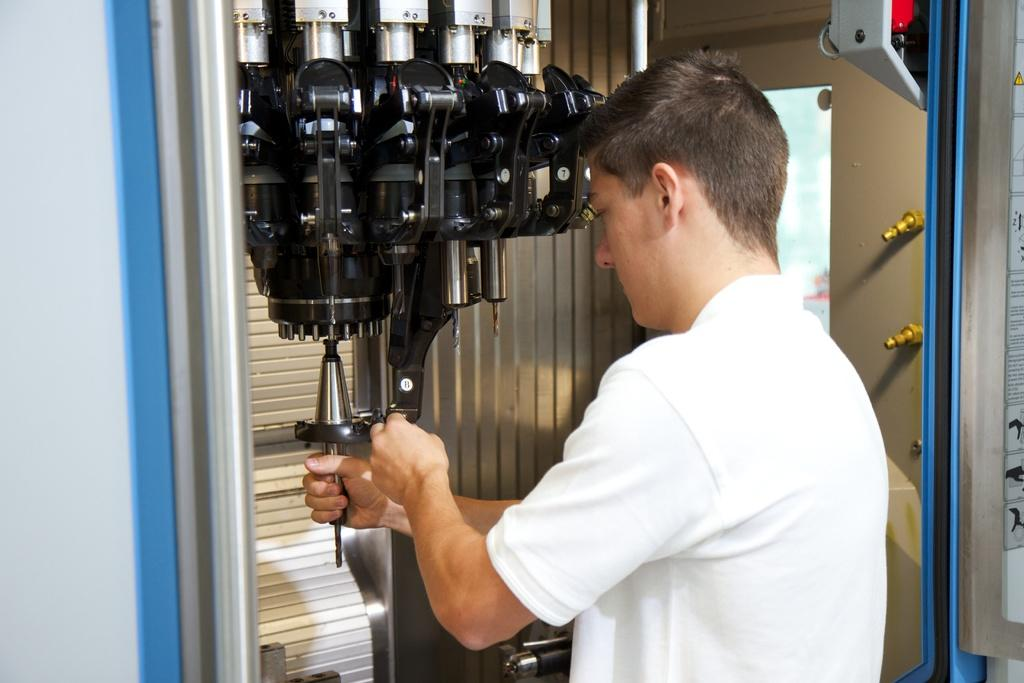What is the main subject of the image? There is a person standing in the image. Can you describe the person's attire? The person is wearing a white dress. What is the person holding in the image? The person is holding a machine. What is the color of the machine? The machine is in black and ash color. What type of animal can be seen swimming in the water near the person in the image? There is no animal or water present in the image; it only features a person holding a machine. 